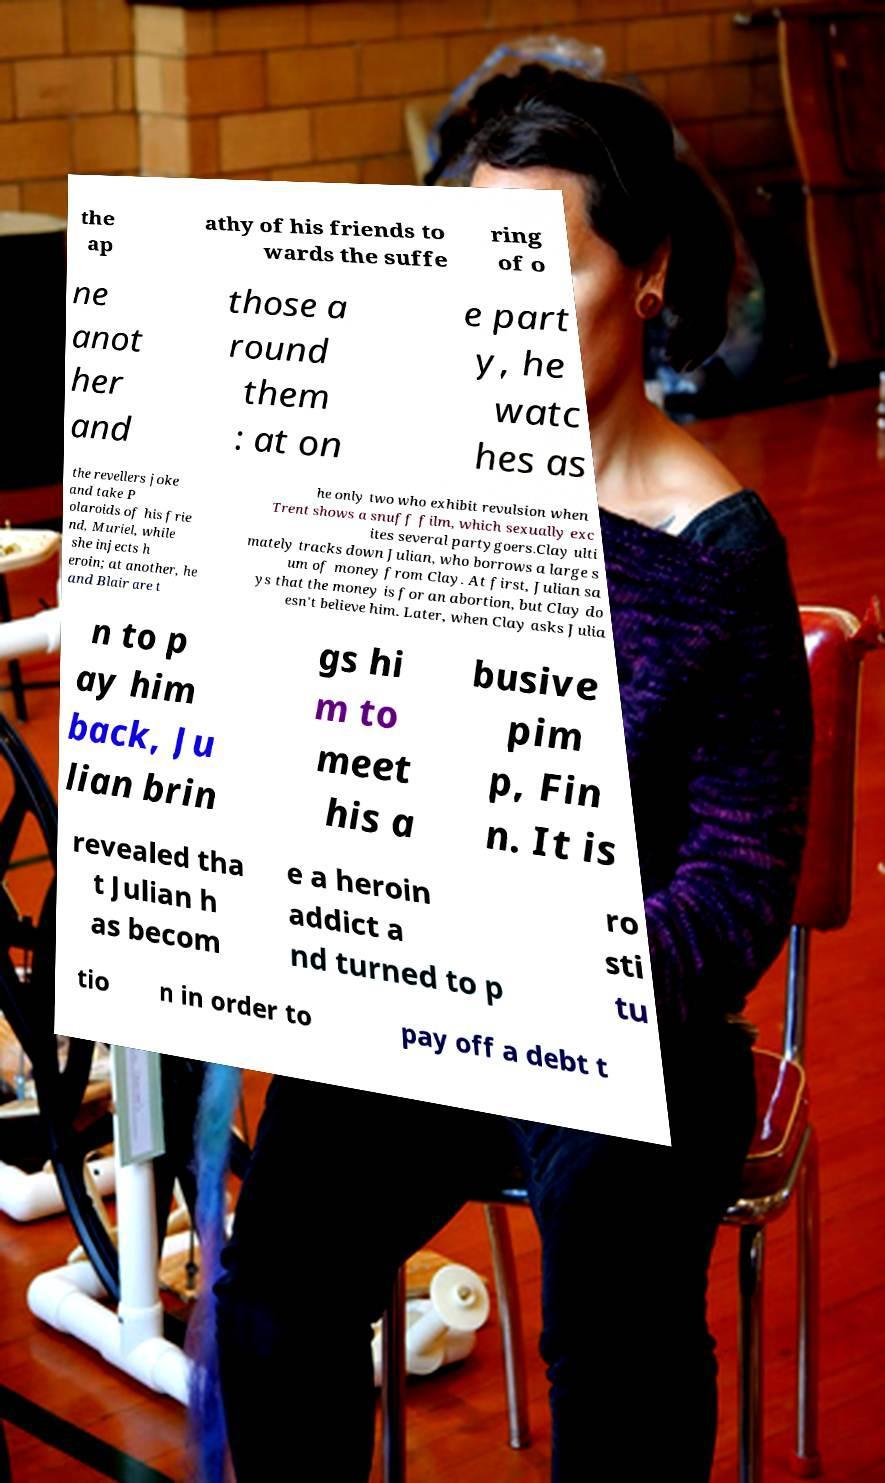Please identify and transcribe the text found in this image. the ap athy of his friends to wards the suffe ring of o ne anot her and those a round them : at on e part y, he watc hes as the revellers joke and take P olaroids of his frie nd, Muriel, while she injects h eroin; at another, he and Blair are t he only two who exhibit revulsion when Trent shows a snuff film, which sexually exc ites several partygoers.Clay ulti mately tracks down Julian, who borrows a large s um of money from Clay. At first, Julian sa ys that the money is for an abortion, but Clay do esn't believe him. Later, when Clay asks Julia n to p ay him back, Ju lian brin gs hi m to meet his a busive pim p, Fin n. It is revealed tha t Julian h as becom e a heroin addict a nd turned to p ro sti tu tio n in order to pay off a debt t 